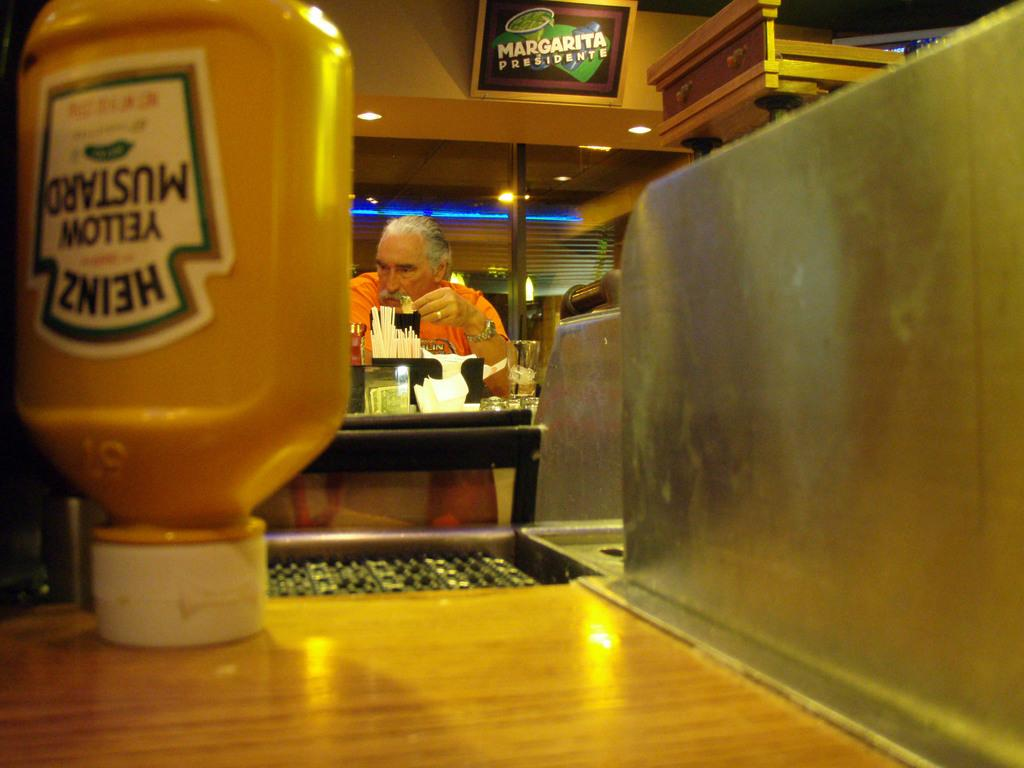<image>
Write a terse but informative summary of the picture. In the foreground a bottle of Heinz Mustard sits on its cap. 